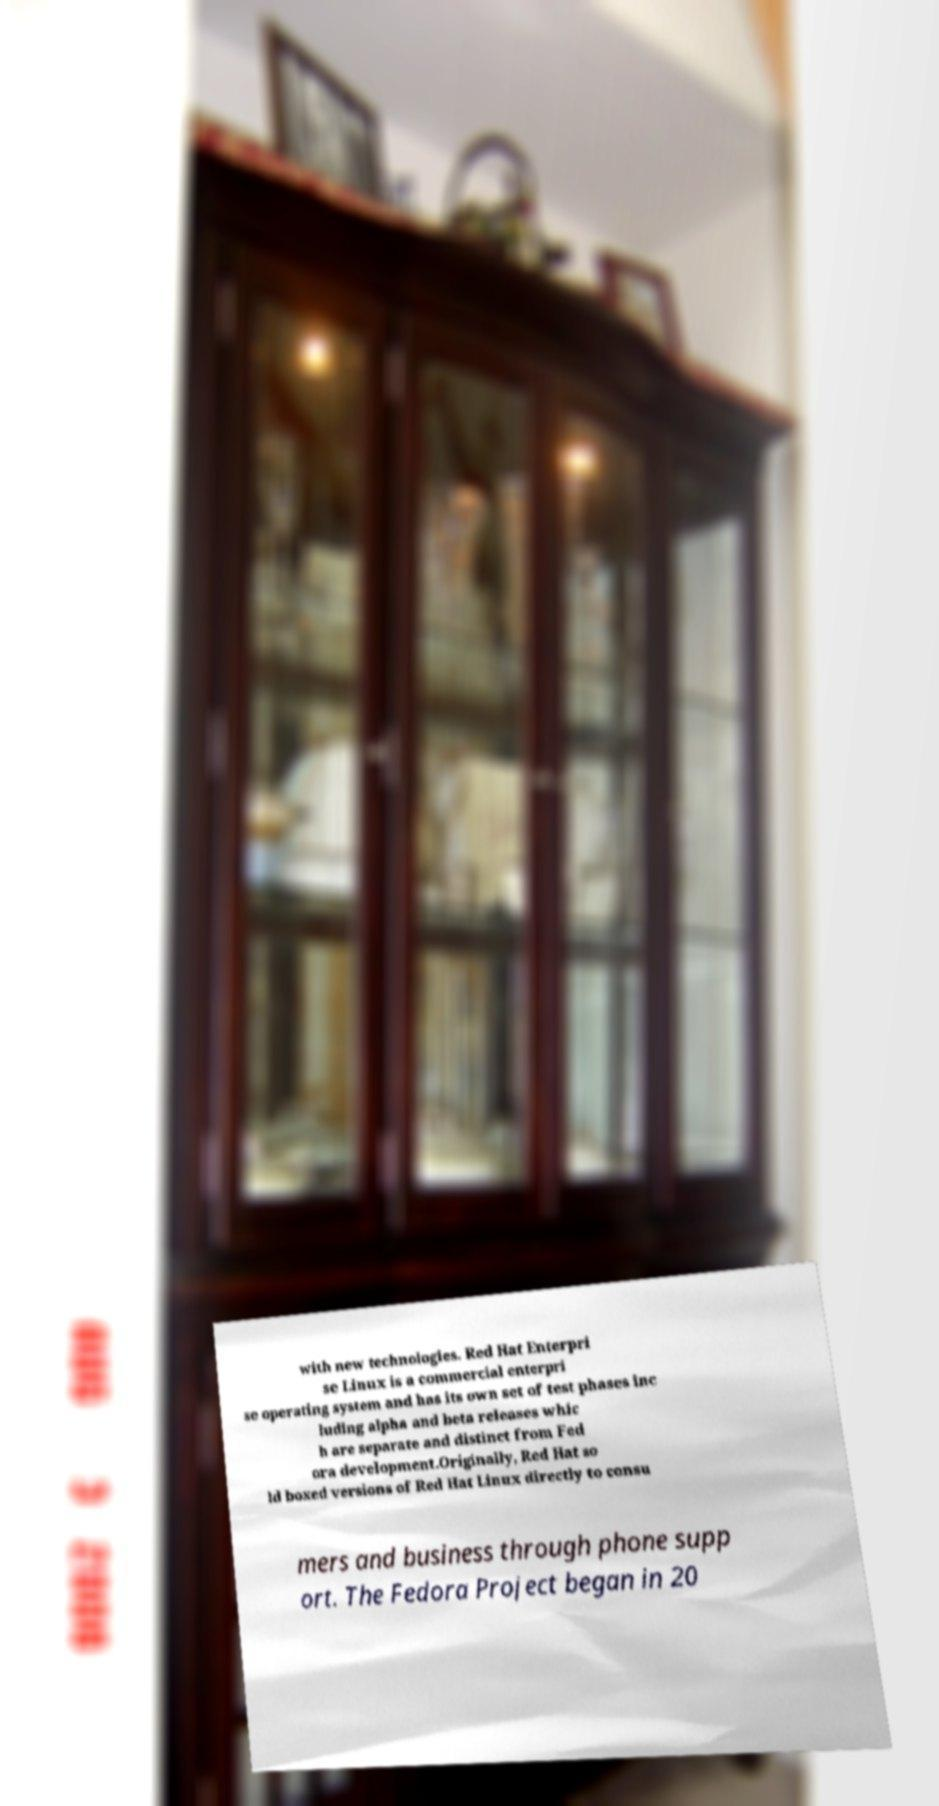Can you read and provide the text displayed in the image?This photo seems to have some interesting text. Can you extract and type it out for me? with new technologies. Red Hat Enterpri se Linux is a commercial enterpri se operating system and has its own set of test phases inc luding alpha and beta releases whic h are separate and distinct from Fed ora development.Originally, Red Hat so ld boxed versions of Red Hat Linux directly to consu mers and business through phone supp ort. The Fedora Project began in 20 